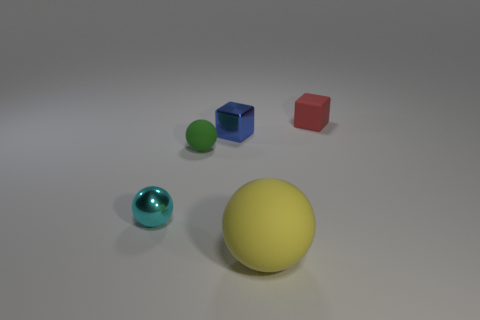There is a cyan ball that is the same material as the small blue thing; what size is it?
Your answer should be compact. Small. What is the shape of the tiny rubber thing right of the green rubber sphere?
Keep it short and to the point. Cube. The metal ball that is the same size as the red block is what color?
Your response must be concise. Cyan. There is a small cyan metallic object; is its shape the same as the red object behind the small green object?
Make the answer very short. No. What is the material of the sphere that is on the right side of the small matte object that is to the left of the ball right of the blue object?
Your answer should be very brief. Rubber. How many large things are either yellow spheres or matte blocks?
Your response must be concise. 1. How many other things are the same size as the cyan shiny object?
Give a very brief answer. 3. Do the rubber object that is right of the big matte thing and the big thing have the same shape?
Your response must be concise. No. The other metal thing that is the same shape as the small green object is what color?
Make the answer very short. Cyan. Is the number of tiny green things that are on the right side of the small shiny block the same as the number of small cyan rubber cylinders?
Keep it short and to the point. Yes. 